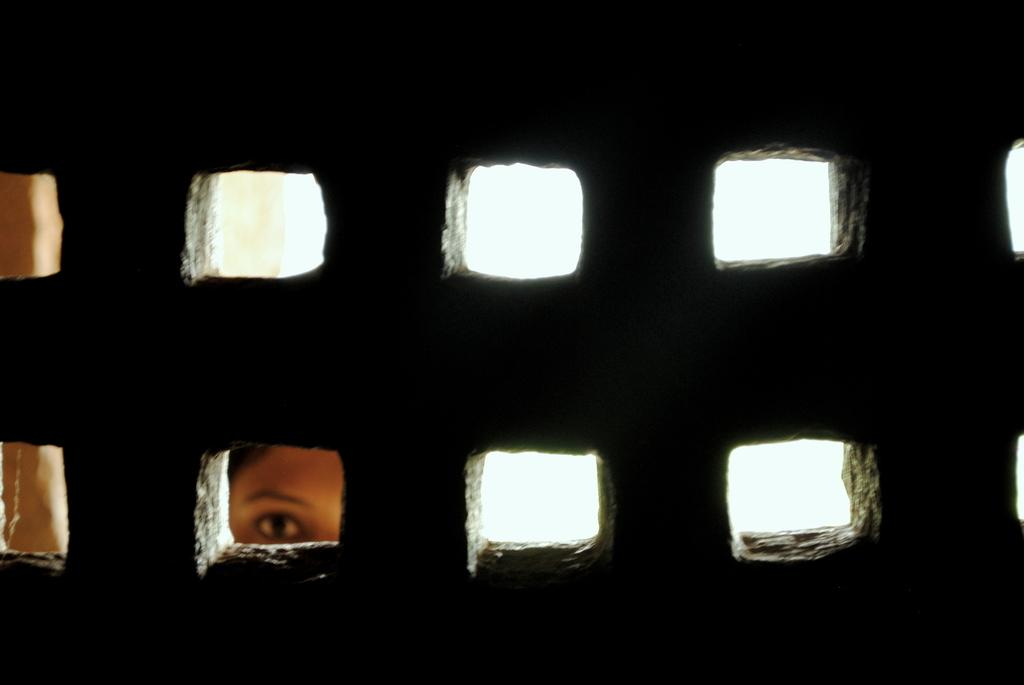Who is present in the image? There is a woman in the image. What is the woman doing in the image? The woman is looking through a hole in a wall. What type of skate is the woman using to look through the hole in the image? There is no skate present in the image; the woman is simply looking through a hole in a wall. Can you tell me what the woman's father thinks about her actions in the image? There is no information about the woman's father or his opinion in the image. What material is the wall made of, based on the image? The image does not provide enough information to determine the material of the wall. 